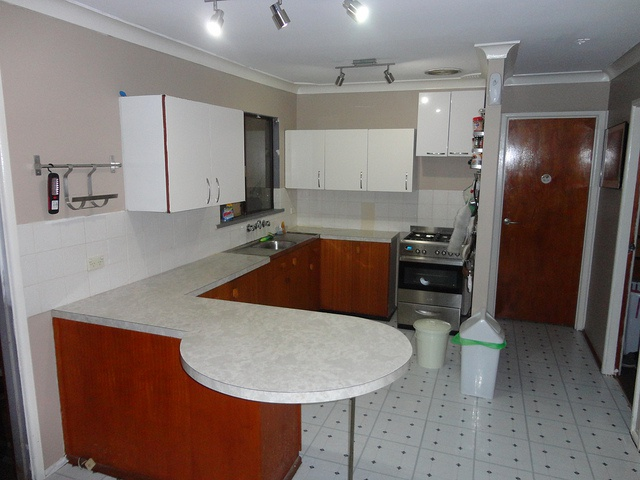Describe the objects in this image and their specific colors. I can see oven in gray, black, and darkgray tones and sink in gray and black tones in this image. 